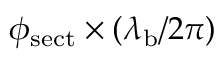Convert formula to latex. <formula><loc_0><loc_0><loc_500><loc_500>\phi _ { s e c t } \times ( \lambda _ { b } / 2 \pi )</formula> 